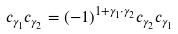<formula> <loc_0><loc_0><loc_500><loc_500>c _ { \gamma _ { 1 } } c _ { \gamma _ { 2 } } = ( - 1 ) ^ { 1 + \gamma _ { 1 } \cdot \gamma _ { 2 } } c _ { \gamma _ { 2 } } c _ { \gamma _ { 1 } }</formula> 